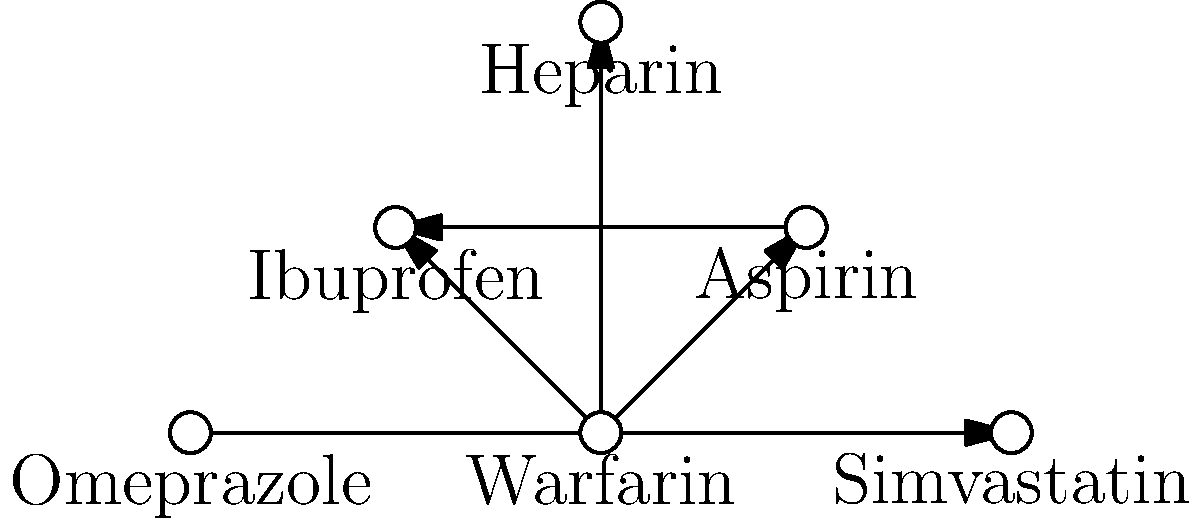Based on the network diagram of drug interactions, which medication is most likely to increase the risk of bleeding when combined with Warfarin? To answer this question, we need to analyze the network diagram and understand the interactions between drugs:

1. Warfarin is at the center of the diagram, connected to three other drugs: Aspirin, Ibuprofen, and Heparin.

2. All three connections are represented by arrows pointing away from Warfarin, indicating that Warfarin interacts with these drugs.

3. Aspirin and Ibuprofen are also connected to each other, suggesting a similar mechanism of action or effect.

4. Heparin is only connected to Warfarin.

5. Omeprazole and Simvastatin are connected but separate from the main group, indicating they interact with each other but not with Warfarin or the other drugs in this context.

6. Among the drugs connected to Warfarin, Heparin is known to be an anticoagulant, like Warfarin. Combining two anticoagulants significantly increases the risk of bleeding.

7. Aspirin and Ibuprofen are both NSAIDs (Non-Steroidal Anti-Inflammatory Drugs) that can also increase bleeding risk, but to a lesser extent than another anticoagulant.

Therefore, based on this network diagram and pharmacological knowledge, Heparin is most likely to increase the risk of bleeding when combined with Warfarin.
Answer: Heparin 